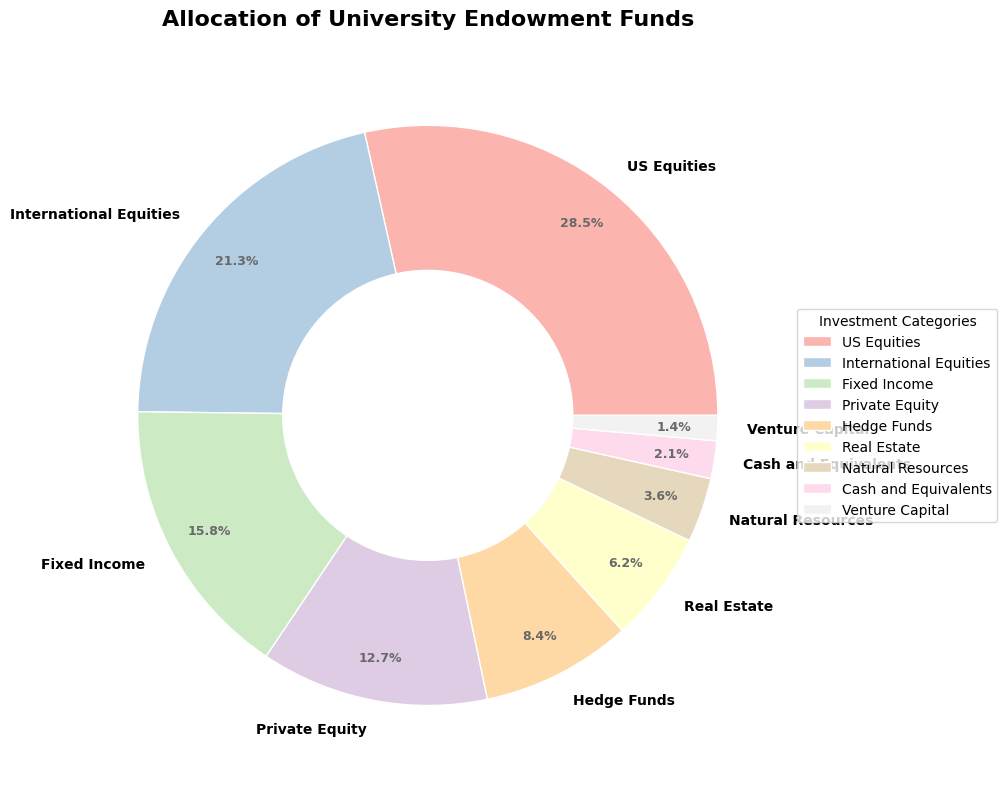Which category has the highest allocation percentage? To find the category with the highest allocation, look at the labels and corresponding percentages. The category with the highest value is US Equities at 28.5%.
Answer: US Equities What is the combined percentage of Fixed Income and Hedge Funds? Add the percentages of Fixed Income (15.8%) and Hedge Funds (8.4%). The combined percentage is 15.8% + 8.4% = 24.2%.
Answer: 24.2% Compare the allocation of Private Equity and Real Estate. Which one has a higher percentage? Compare the percentages of Private Equity (12.7%) and Real Estate (6.2%). Private Equity has a higher percentage.
Answer: Private Equity What is the difference in percentage between International Equities and Natural Resources? Subtract the percentage of Natural Resources (3.6%) from International Equities (21.3%). The difference is 21.3% - 3.6% = 17.7%.
Answer: 17.7% What percentage of endowment funds is allocated to Cash and Equivalents? Observe the label and percentage for Cash and Equivalents, which is 2.1%.
Answer: 2.1% Which category has the smallest allocation percentage and what is it? Find the category with the smallest value. Venture Capital has the smallest allocation percentage at 1.4%.
Answer: Venture Capital Is the sum of Real Estate and Natural Resources allocation more than the allocation of US Equities? Add the percentages of Real Estate (6.2%) and Natural Resources (3.6%). The sum is 6.2% + 3.6% = 9.8%, which is less than US Equities' 28.5%.
Answer: No What is the combined allocation percentage of all equity categories (US Equities, International Equities, Private Equity, and Venture Capital)? Add the percentages of US Equities (28.5%), International Equities (21.3%), Private Equity (12.7%), and Venture Capital (1.4%). The combined percentage is 28.5% + 21.3% + 12.7% + 1.4% = 63.9%.
Answer: 63.9% How much more is allocated to US Equities compared to Cash and Equivalents? Subtract the percentage of Cash and Equivalents (2.1%) from US Equities (28.5%). The difference is 28.5% - 2.1% = 26.4%.
Answer: 26.4% What is the average allocation percentage of all categories? Sum all the percentages (28.5 + 21.3 + 15.8 + 12.7 + 8.4 + 6.2 + 3.6 + 2.1 + 1.4) which equals 100. Then divide by the number of categories (9). The average is 100 / 9 = 11.1%.
Answer: 11.1% 